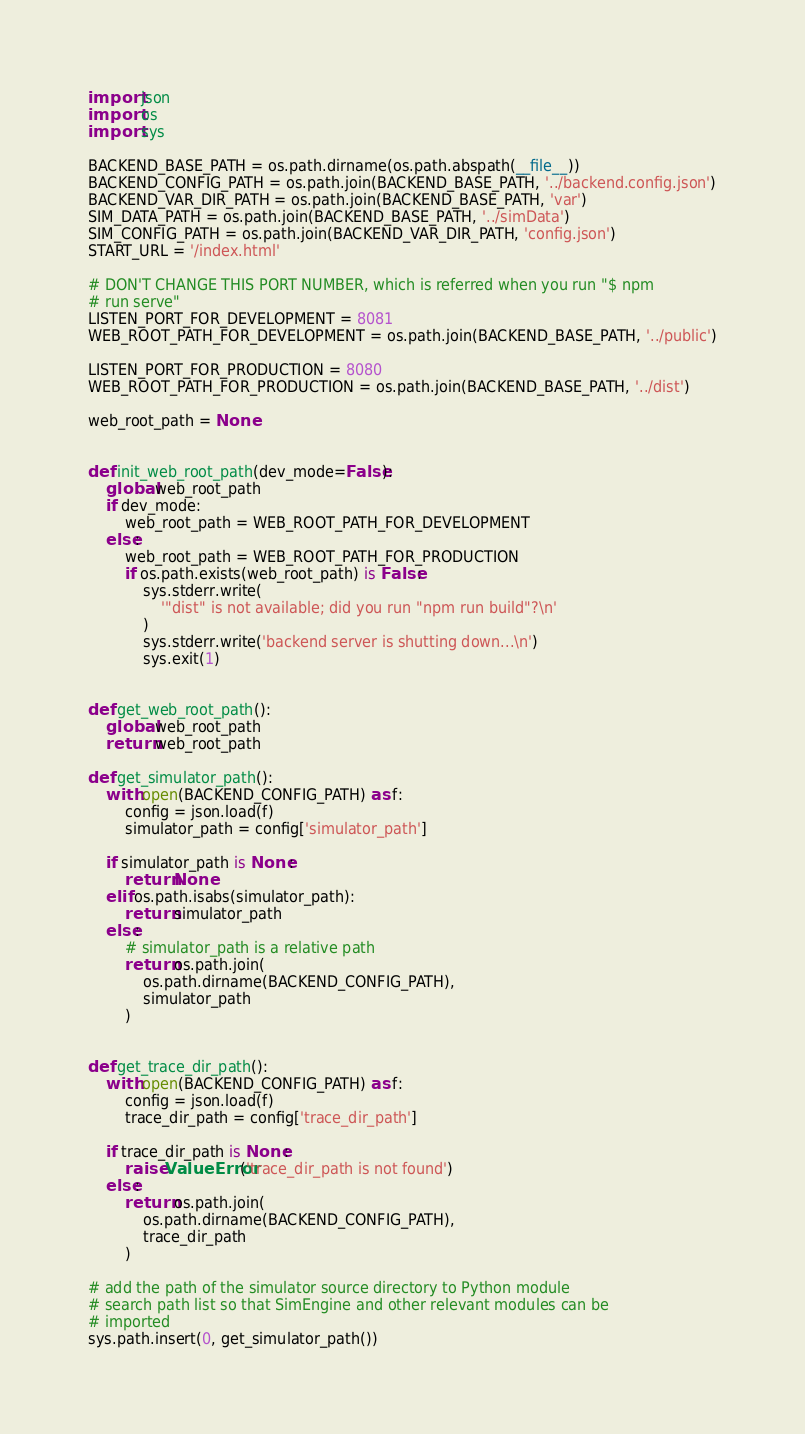<code> <loc_0><loc_0><loc_500><loc_500><_Python_>import json
import os
import sys

BACKEND_BASE_PATH = os.path.dirname(os.path.abspath(__file__))
BACKEND_CONFIG_PATH = os.path.join(BACKEND_BASE_PATH, '../backend.config.json')
BACKEND_VAR_DIR_PATH = os.path.join(BACKEND_BASE_PATH, 'var')
SIM_DATA_PATH = os.path.join(BACKEND_BASE_PATH, '../simData')
SIM_CONFIG_PATH = os.path.join(BACKEND_VAR_DIR_PATH, 'config.json')
START_URL = '/index.html'

# DON'T CHANGE THIS PORT NUMBER, which is referred when you run "$ npm
# run serve"
LISTEN_PORT_FOR_DEVELOPMENT = 8081
WEB_ROOT_PATH_FOR_DEVELOPMENT = os.path.join(BACKEND_BASE_PATH, '../public')

LISTEN_PORT_FOR_PRODUCTION = 8080
WEB_ROOT_PATH_FOR_PRODUCTION = os.path.join(BACKEND_BASE_PATH, '../dist')

web_root_path = None


def init_web_root_path(dev_mode=False):
    global web_root_path
    if dev_mode:
        web_root_path = WEB_ROOT_PATH_FOR_DEVELOPMENT
    else:
        web_root_path = WEB_ROOT_PATH_FOR_PRODUCTION
        if os.path.exists(web_root_path) is False:
            sys.stderr.write(
                '"dist" is not available; did you run "npm run build"?\n'
            )
            sys.stderr.write('backend server is shutting down...\n')
            sys.exit(1)


def get_web_root_path():
    global web_root_path
    return web_root_path

def get_simulator_path():
    with open(BACKEND_CONFIG_PATH) as f:
        config = json.load(f)
        simulator_path = config['simulator_path']

    if simulator_path is None:
        return None
    elif os.path.isabs(simulator_path):
        return simulator_path
    else:
        # simulator_path is a relative path
        return os.path.join(
            os.path.dirname(BACKEND_CONFIG_PATH),
            simulator_path
        )


def get_trace_dir_path():
    with open(BACKEND_CONFIG_PATH) as f:
        config = json.load(f)
        trace_dir_path = config['trace_dir_path']

    if trace_dir_path is None:
        raise ValueError('trace_dir_path is not found')
    else:
        return os.path.join(
            os.path.dirname(BACKEND_CONFIG_PATH),
            trace_dir_path
        )

# add the path of the simulator source directory to Python module
# search path list so that SimEngine and other relevant modules can be
# imported
sys.path.insert(0, get_simulator_path())
</code> 